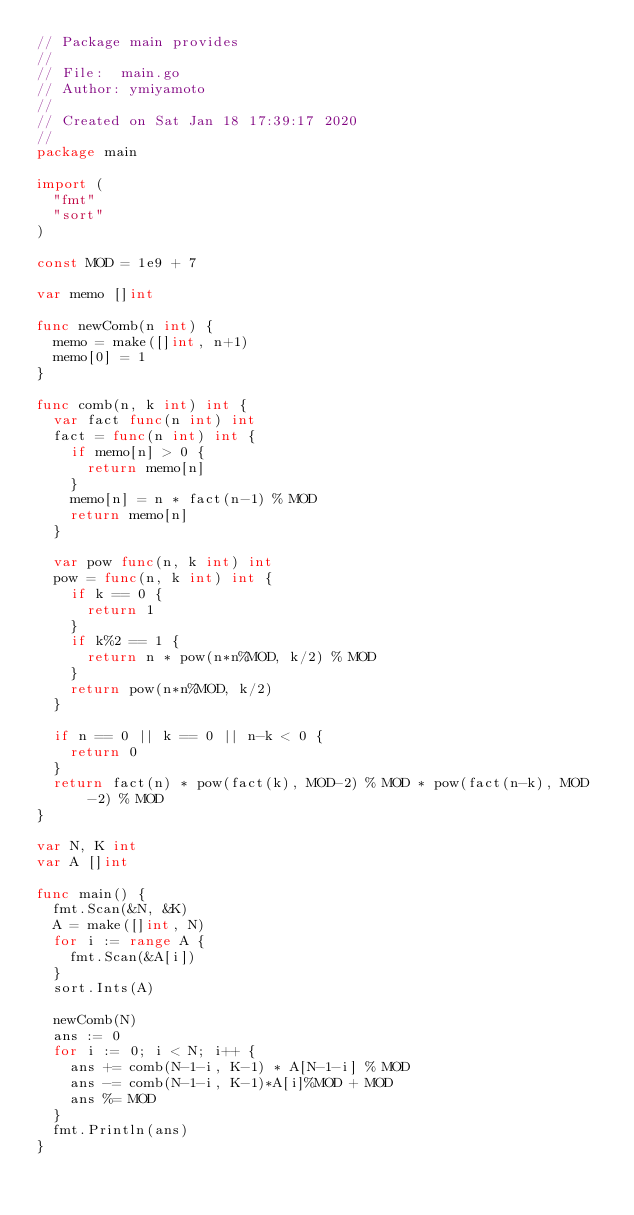Convert code to text. <code><loc_0><loc_0><loc_500><loc_500><_Go_>// Package main provides
//
// File:  main.go
// Author: ymiyamoto
//
// Created on Sat Jan 18 17:39:17 2020
//
package main

import (
	"fmt"
	"sort"
)

const MOD = 1e9 + 7

var memo []int

func newComb(n int) {
	memo = make([]int, n+1)
	memo[0] = 1
}

func comb(n, k int) int {
	var fact func(n int) int
	fact = func(n int) int {
		if memo[n] > 0 {
			return memo[n]
		}
		memo[n] = n * fact(n-1) % MOD
		return memo[n]
	}

	var pow func(n, k int) int
	pow = func(n, k int) int {
		if k == 0 {
			return 1
		}
		if k%2 == 1 {
			return n * pow(n*n%MOD, k/2) % MOD
		}
		return pow(n*n%MOD, k/2)
	}

	if n == 0 || k == 0 || n-k < 0 {
		return 0
	}
	return fact(n) * pow(fact(k), MOD-2) % MOD * pow(fact(n-k), MOD-2) % MOD
}

var N, K int
var A []int

func main() {
	fmt.Scan(&N, &K)
	A = make([]int, N)
	for i := range A {
		fmt.Scan(&A[i])
	}
	sort.Ints(A)

	newComb(N)
	ans := 0
	for i := 0; i < N; i++ {
		ans += comb(N-1-i, K-1) * A[N-1-i] % MOD
		ans -= comb(N-1-i, K-1)*A[i]%MOD + MOD
		ans %= MOD
	}
	fmt.Println(ans)
}
</code> 